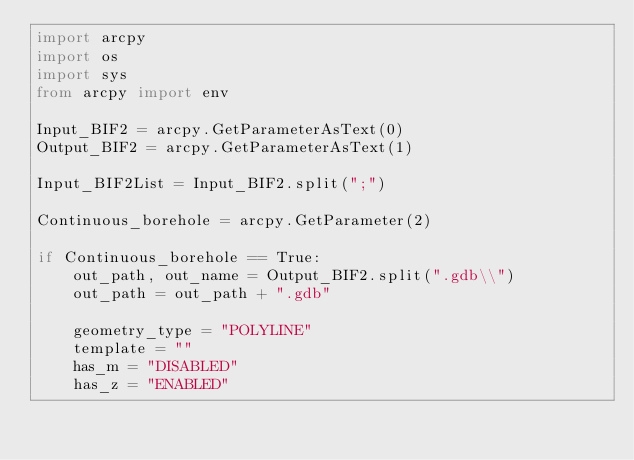Convert code to text. <code><loc_0><loc_0><loc_500><loc_500><_Python_>import arcpy
import os
import sys
from arcpy import env

Input_BIF2 = arcpy.GetParameterAsText(0)
Output_BIF2 = arcpy.GetParameterAsText(1)

Input_BIF2List = Input_BIF2.split(";")

Continuous_borehole = arcpy.GetParameter(2)

if Continuous_borehole == True:
    out_path, out_name = Output_BIF2.split(".gdb\\")
    out_path = out_path + ".gdb"

    geometry_type = "POLYLINE"
    template = ""
    has_m = "DISABLED"
    has_z = "ENABLED"
</code> 